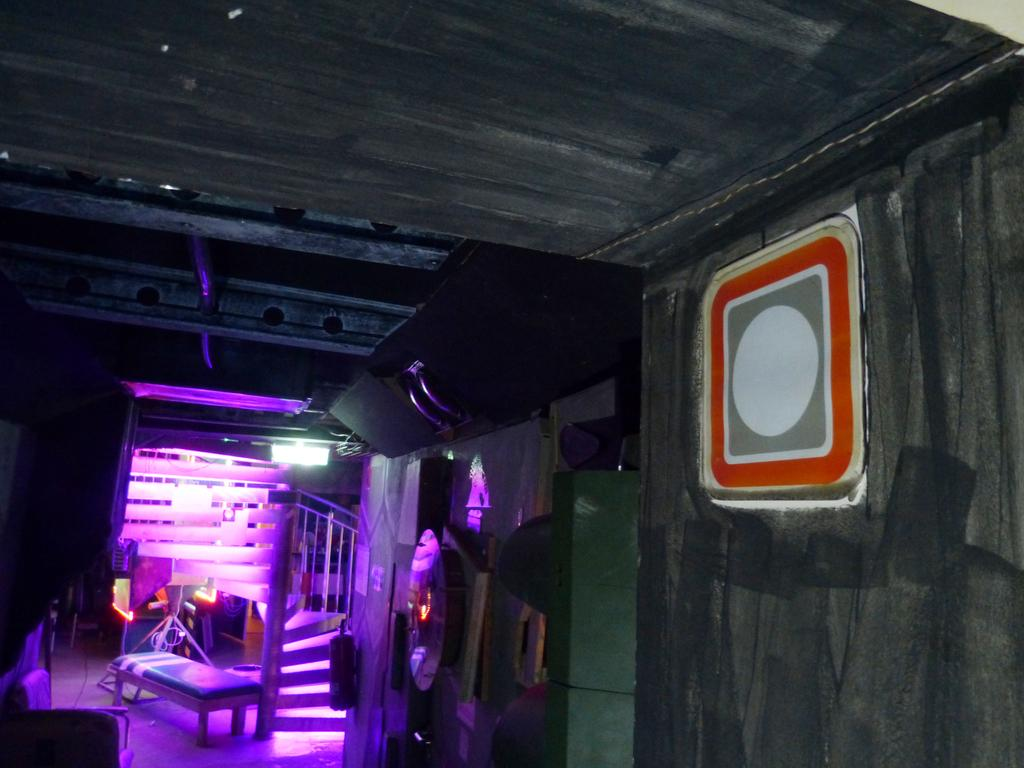What type of furniture is on the floor in the image? There is a bench on the floor in the image. What can be seen illuminating the area in the image? There are lights visible in the image. What material is used for some of the objects in the image? There are wooden objects in the image. Can you describe any other objects present in the image? There are other objects present in the image, but their specific details are not mentioned in the provided facts. What color is the hair on the bench in the image? There is no hair present on the bench or in the image. 